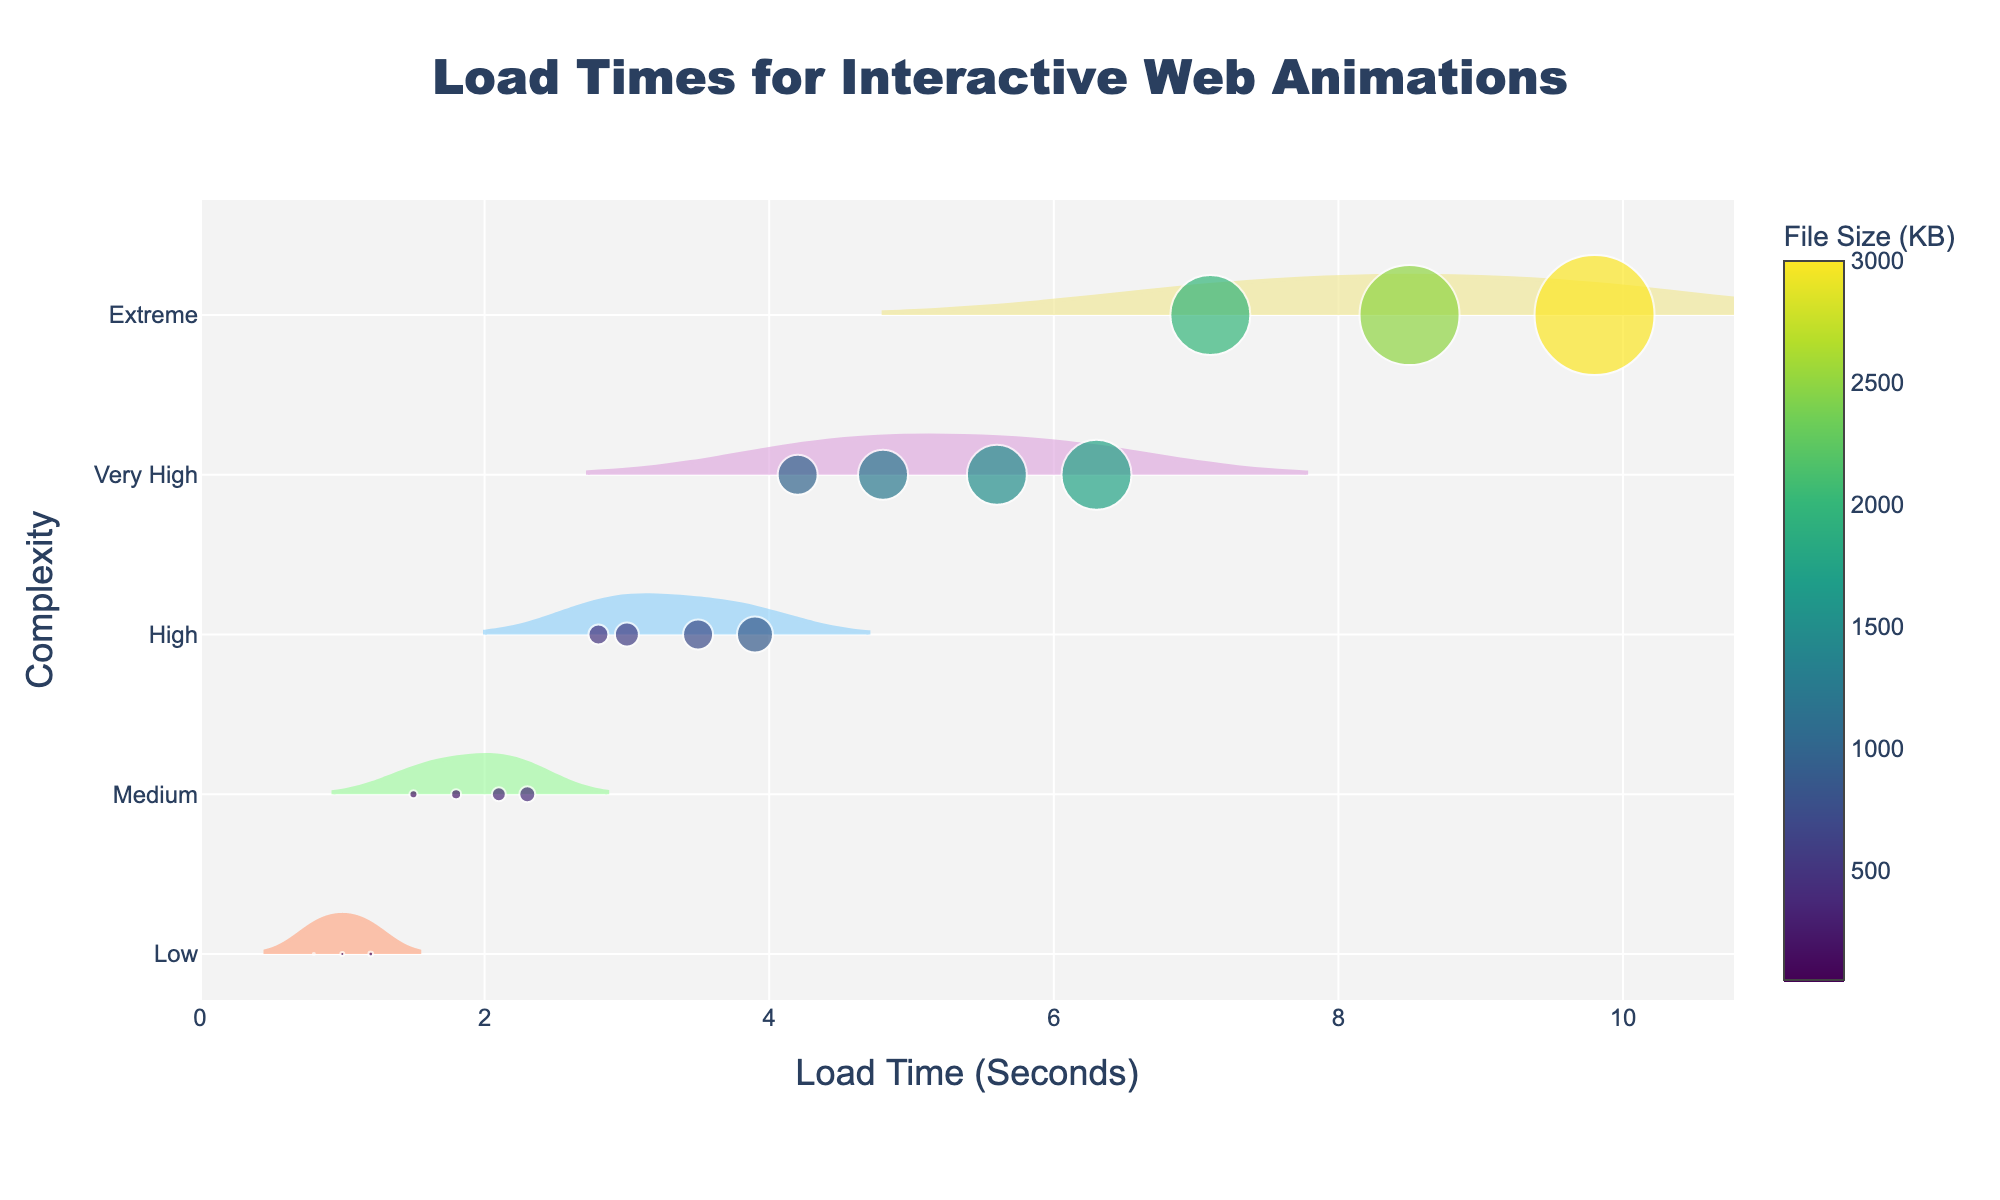How is the data categorized on the y-axis? The y-axis is labeled "Complexity" and categorizes the data into different complexity levels of web animations. These levels are: Low, Medium, High, Very High, and Extreme.
Answer: Complexity levels (Low, Medium, High, Very High, Extreme) Which complexity level shows the longest load times? By looking at the horizontal density plots and scatter points, the Extreme complexity level has the dots furthest to the right, indicating the longest load times.
Answer: Extreme What does the size of each scatter point represent? The size of each scatter point corresponds to the file size of the web animation, with larger points indicating larger file sizes.
Answer: File size Compare the general load times between Low and High complexity levels. Which has higher load times? By observing the scatter points and density plots, the points for the Low complexity level are clustered around shorter load times, while the High complexity level shows longer load times.
Answer: High complexity level How does load time differ between the files with 2500 KB and 750 KB file sizes? To analyze, locate each file size on the color bar and find their positions on the chart. The 2500 KB file has a load time around 8.5 seconds, while the 750 KB file has a load time around 3.5 seconds.
Answer: 2500 KB: 8.5 seconds, 750 KB: 3.5 seconds Which complexity level has the widest range of load times? Observing the density plots, the Extreme complexity level shows the widest spread, indicating a larger range of load times.
Answer: Extreme What are the colors used to represent the various complexity levels? The color map differentiates the complexity levels with specific colors: Low (peach), Medium (light green), High (light blue), Very High (purple), and Extreme (light yellow).
Answer: Low: peach, Medium: light green, High: light blue, Very High: purple, Extreme: light yellow 